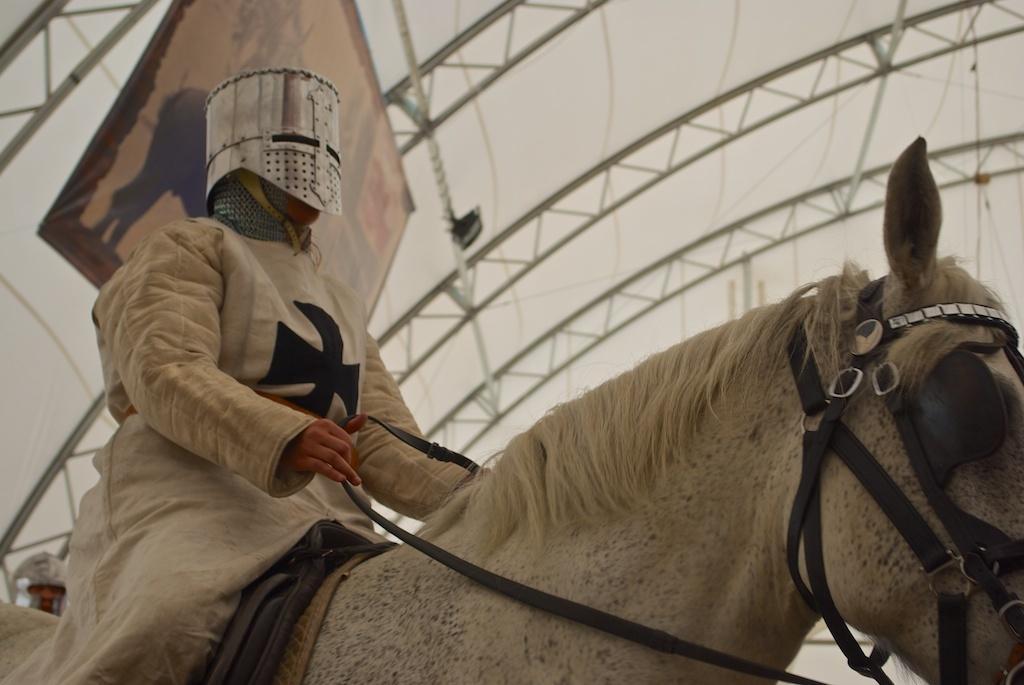Describe this image in one or two sentences. In the foreground of this image, there is a person wearing a white dress and a mask over his head is sitting on a horse and holding the belt. In the background, there is a banner, roof and a person's head at the bottom left. 